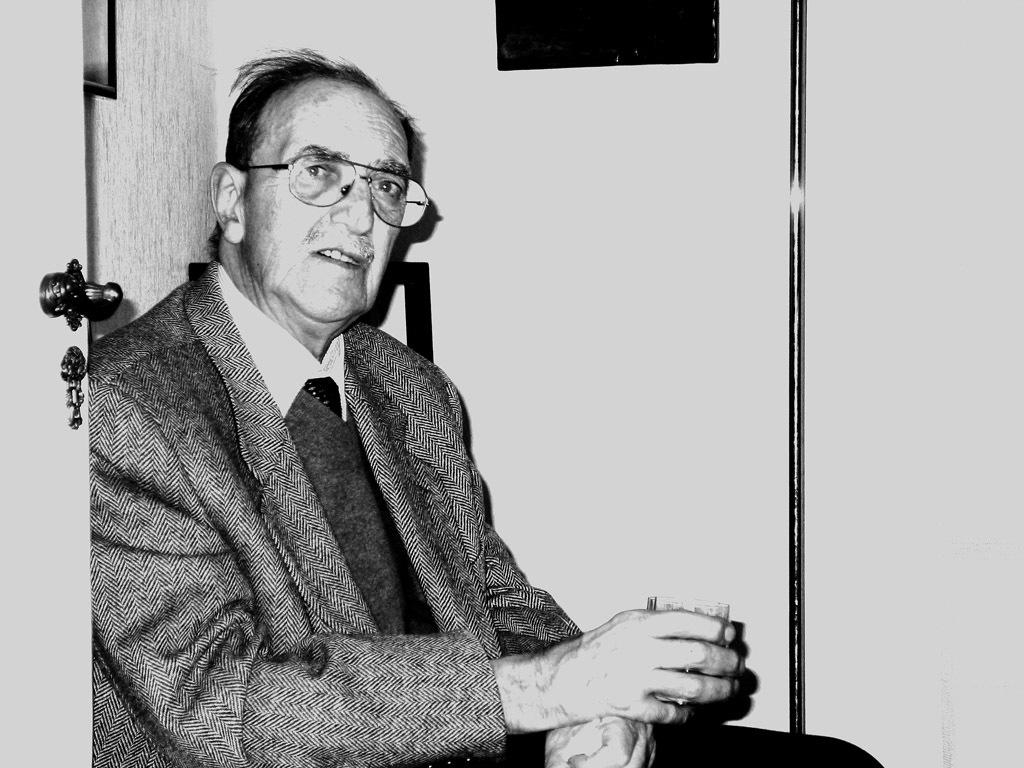What is the man in the image doing? The man is sitting in the image. What is the man holding in the image? The man is holding a glass. What can be seen on the left side of the image? There is a door on the left side of the image. What is visible in the background of the image? There is a wall in the background of the image. How is the image presented in terms of color? The image is black and white. What type of substance is the man using to twist the door handle in the image? There is no indication in the image that the man is twisting a door handle or using any substance to do so. 